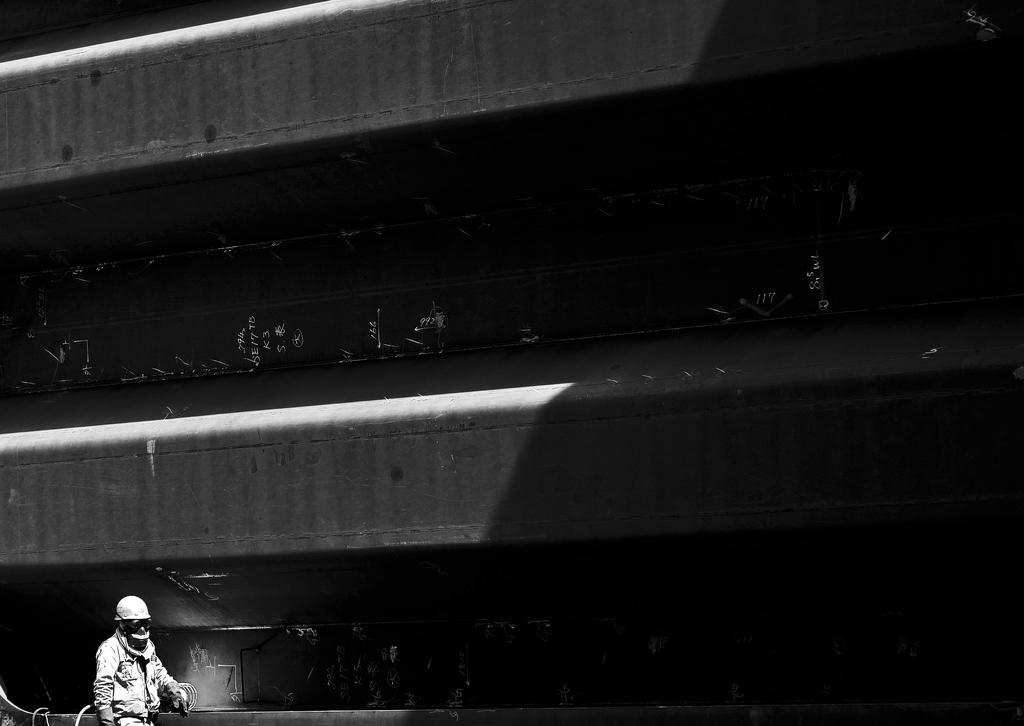What is the main subject in the middle of the image? There might be a bridge in the middle of the image. Can you describe the person at the bottom of the image? A person wearing a helmet is visible at the bottom of the image. How much money does the zephyr have in the image? There is no zephyr or money present in the image. What impulse does the person at the bottom of the image have? The provided facts do not give any information about the person's impulses, so we cannot answer this question. 